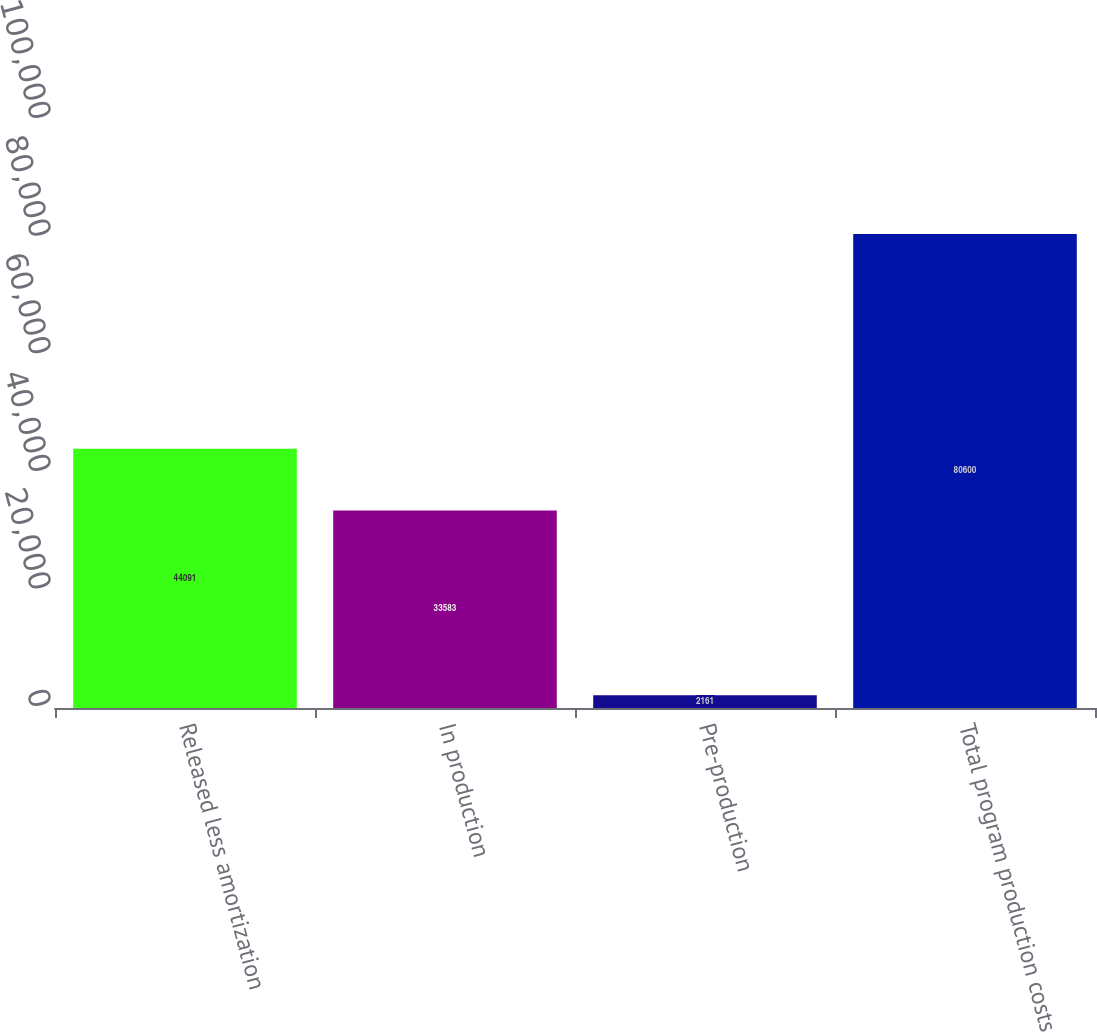Convert chart. <chart><loc_0><loc_0><loc_500><loc_500><bar_chart><fcel>Released less amortization<fcel>In production<fcel>Pre-production<fcel>Total program production costs<nl><fcel>44091<fcel>33583<fcel>2161<fcel>80600<nl></chart> 